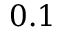Convert formula to latex. <formula><loc_0><loc_0><loc_500><loc_500>0 . 1</formula> 